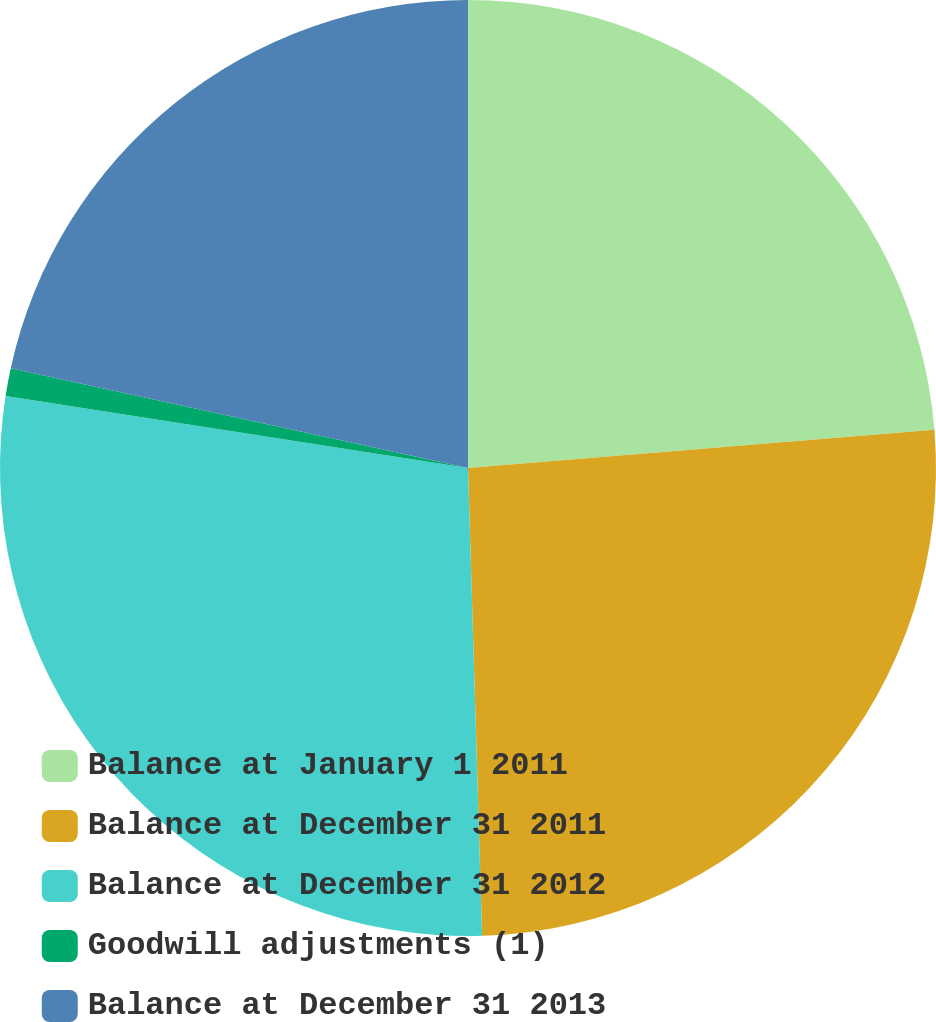Convert chart to OTSL. <chart><loc_0><loc_0><loc_500><loc_500><pie_chart><fcel>Balance at January 1 2011<fcel>Balance at December 31 2011<fcel>Balance at December 31 2012<fcel>Goodwill adjustments (1)<fcel>Balance at December 31 2013<nl><fcel>23.7%<fcel>25.82%<fcel>27.94%<fcel>0.96%<fcel>21.58%<nl></chart> 